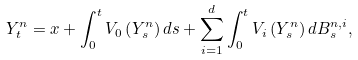<formula> <loc_0><loc_0><loc_500><loc_500>Y _ { t } ^ { n } = x + \int _ { 0 } ^ { t } V _ { 0 } \left ( Y _ { s } ^ { n } \right ) d s + \sum _ { i = 1 } ^ { d } \int _ { 0 } ^ { t } V _ { i } \left ( Y _ { s } ^ { n } \right ) d B _ { s } ^ { n , i } ,</formula> 